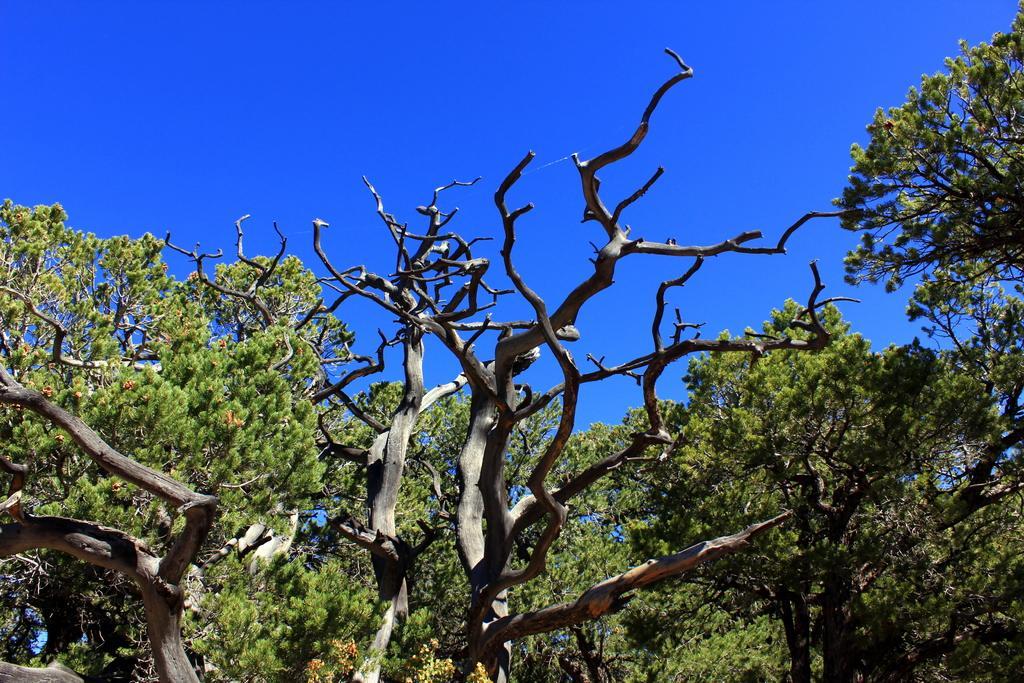In one or two sentences, can you explain what this image depicts? In front of the image there are trees. In the background of the image there is sky. 